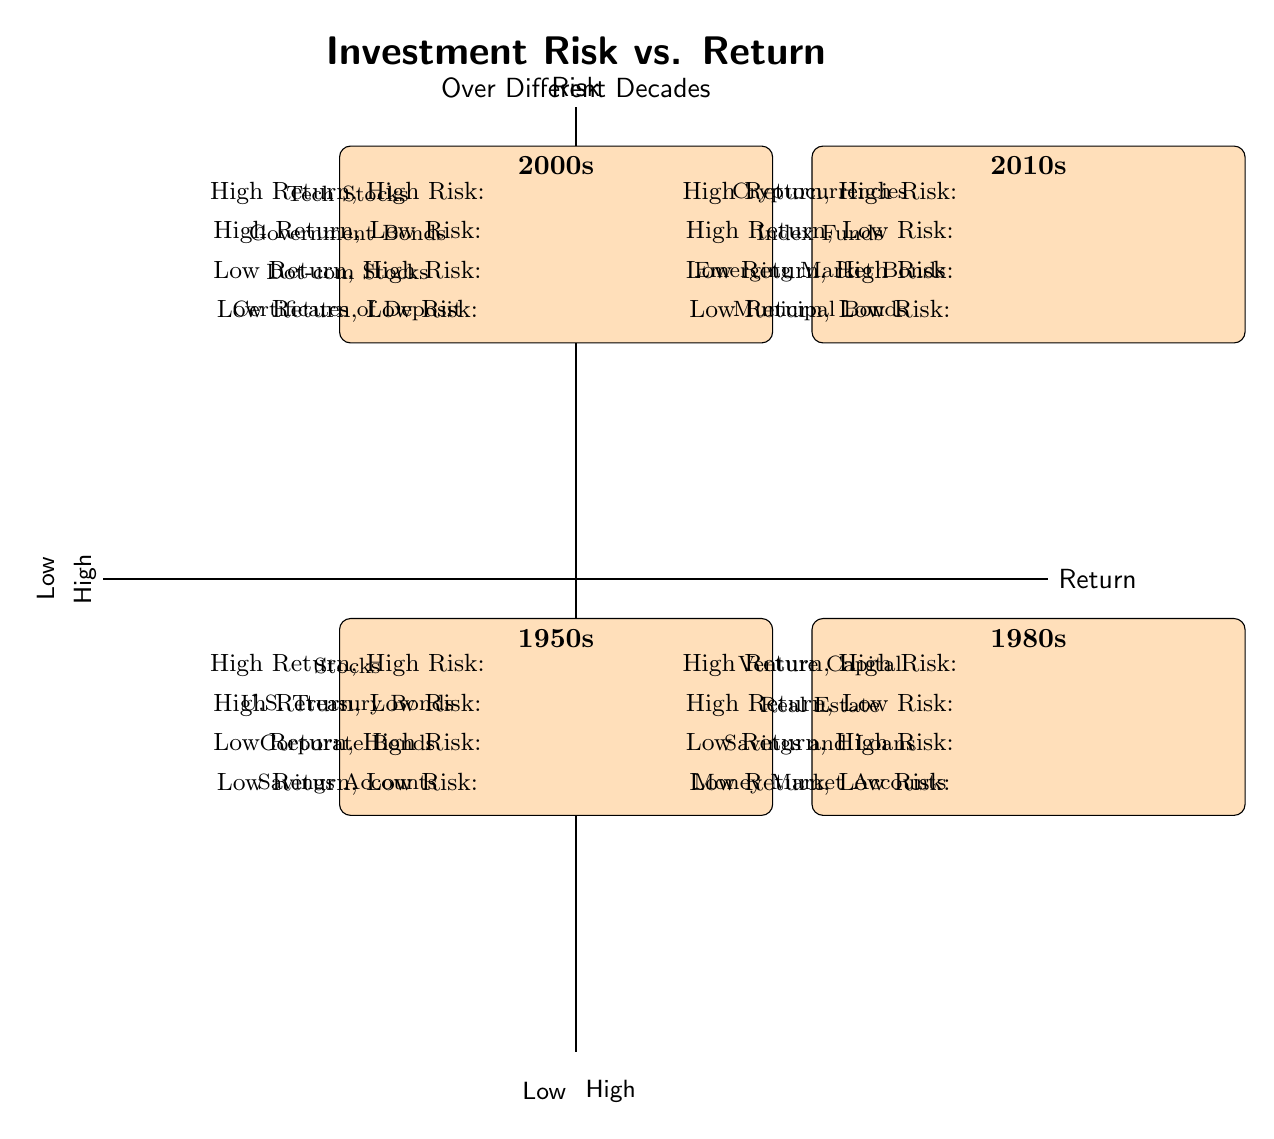What investments are listed under the "High Return, High Risk" category for the 2000s? According to the diagram, the investments listed under the "High Return, High Risk" category for the 2000s are "Tech Stocks". This can be found in the designated quadrant for the 2000s in the diagram.
Answer: Tech Stocks Which decade has "Savings Accounts" in the "Low Return, Low Risk" category? The diagram clearly shows that "Savings Accounts" is placed in the "Low Return, Low Risk" quadrant for the 1950s. Therefore, the answer is derived from identifying the correct category and decade.
Answer: 1950s How many investment types are categorized as "High Return, Low Risk" in the 2010s? In the 2010s quadrant, there are two investment types identified under "High Return, Low Risk": "Index Funds" and "Government Bonds". Thus, we simply count the types listed in that category.
Answer: 2 What is the main difference in the "High Return, High Risk" investments between the 1950s and 1980s? The diagram indicates that the "High Return, High Risk" investment for the 1950s is "Stocks", while for the 1980s, it is "Venture Capital". The main difference lies in the specific types of investments listed for each decade in that category.
Answer: Stocks vs. Venture Capital Which decade presents "Municipal Bonds" as a "Low Return, Low Risk" option? According to the diagram, "Municipal Bonds" are categorized under "Low Return, Low Risk" in the 2010s quadrant. This is identified by locating the specific investment within that quadrant in the respective decade's section.
Answer: 2010s In which quadrant would you find "Corporate Bonds"? "Corporate Bonds" are found in the "Low Return, High Risk" quadrant for the 1950s. This is determined by examining the quadrants and identifying the placement of "Corporate Bonds".
Answer: Low Return, High Risk Compare the investment categories for the 1980s and 2010s. Which has more options in "Low Return, High Risk"? The 1980s present one option, "Savings and Loans", in the "Low Return, High Risk" category, while the 2010s show "Emerging Market Bonds". Both decades have one option, indicating an equal count in this specific category.
Answer: Equal (1 each) What type of investment appears most frequently across all decades in the "High Return, Low Risk" category? The investment types categorized as "High Return, Low Risk" across decades are U.S. Treasury Bonds (1950s), Real Estate (1980s), Government Bonds (2000s), and Index Funds (2010s). No type appears more frequently, as all are different.
Answer: None 